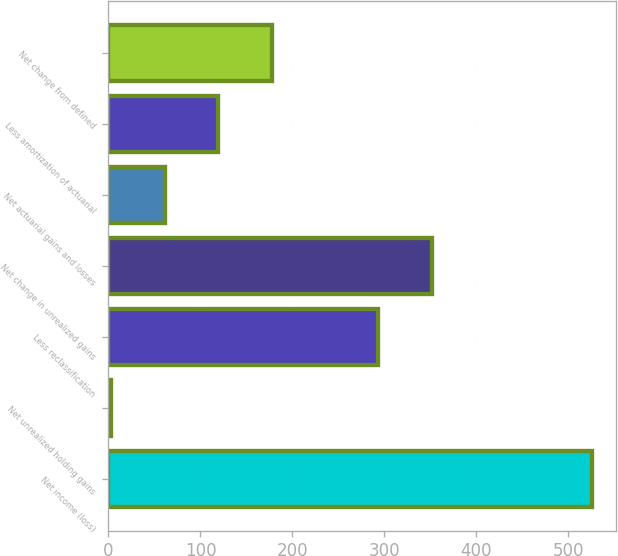Convert chart. <chart><loc_0><loc_0><loc_500><loc_500><bar_chart><fcel>Net income (loss)<fcel>Net unrealized holding gains<fcel>Less reclassification<fcel>Net change in unrealized gains<fcel>Net actuarial gains and losses<fcel>Less amortization of actuarial<fcel>Net change from defined<nl><fcel>525.9<fcel>3<fcel>293.5<fcel>351.6<fcel>61.1<fcel>119.2<fcel>177.3<nl></chart> 